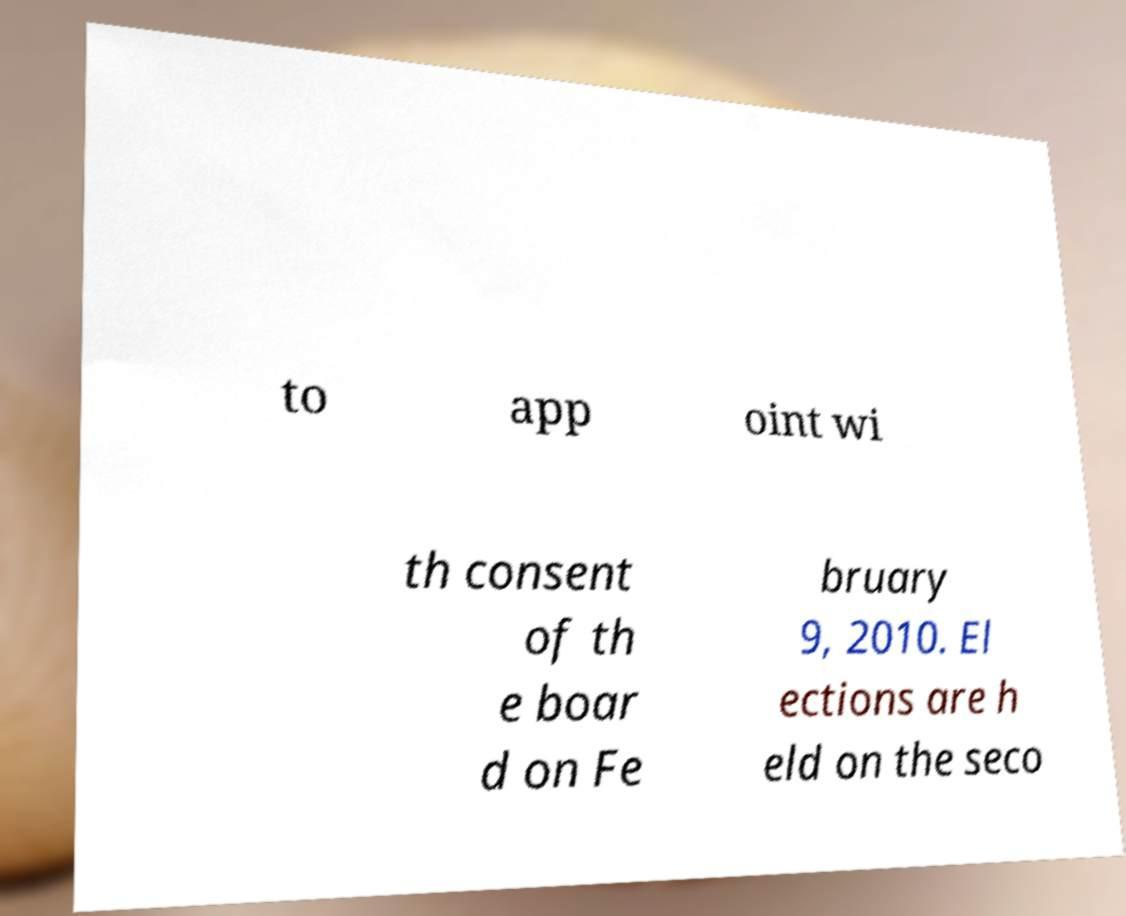Could you extract and type out the text from this image? to app oint wi th consent of th e boar d on Fe bruary 9, 2010. El ections are h eld on the seco 